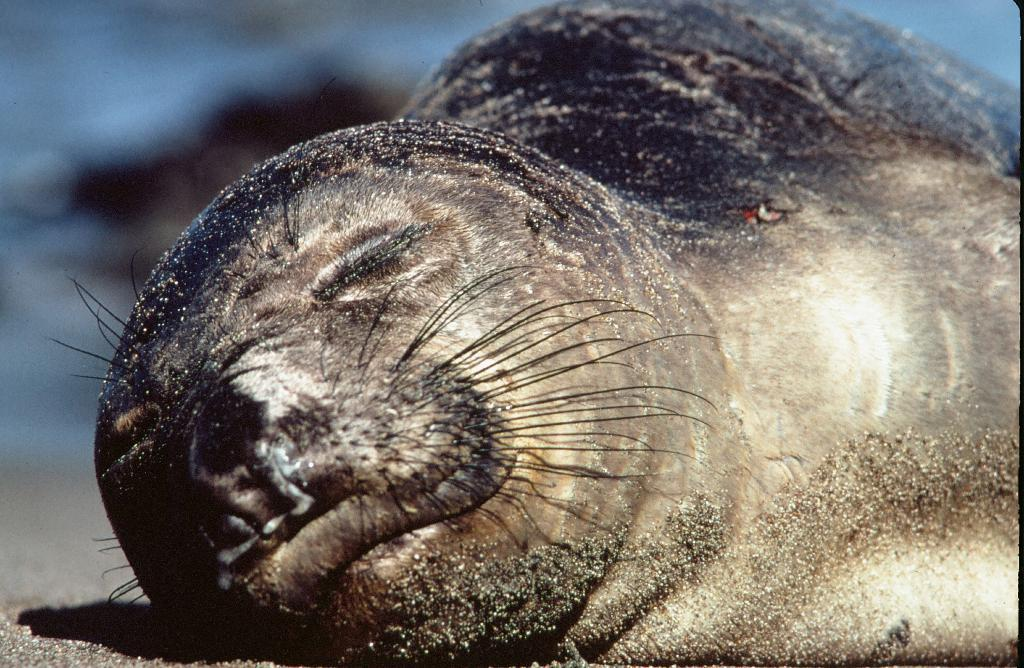What animal is in the image? There is a sloth in the image. What is the sloth doing in the image? The sloth is sleeping in the image. Where is the sloth located in the image? The sloth is on the ground in the image. What type of surface is at the bottom of the image? There is sand at the bottom of the image. What type of watch is the sloth wearing in the image? There is no watch visible in the image, as the sloth is sleeping and not wearing any accessories. 